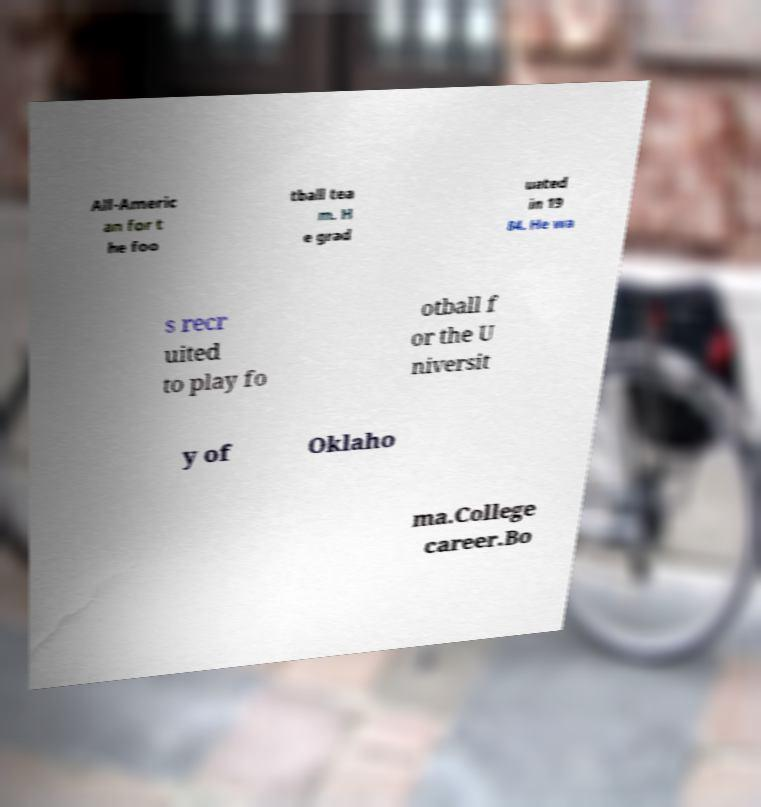Could you extract and type out the text from this image? All-Americ an for t he foo tball tea m. H e grad uated in 19 84. He wa s recr uited to play fo otball f or the U niversit y of Oklaho ma.College career.Bo 